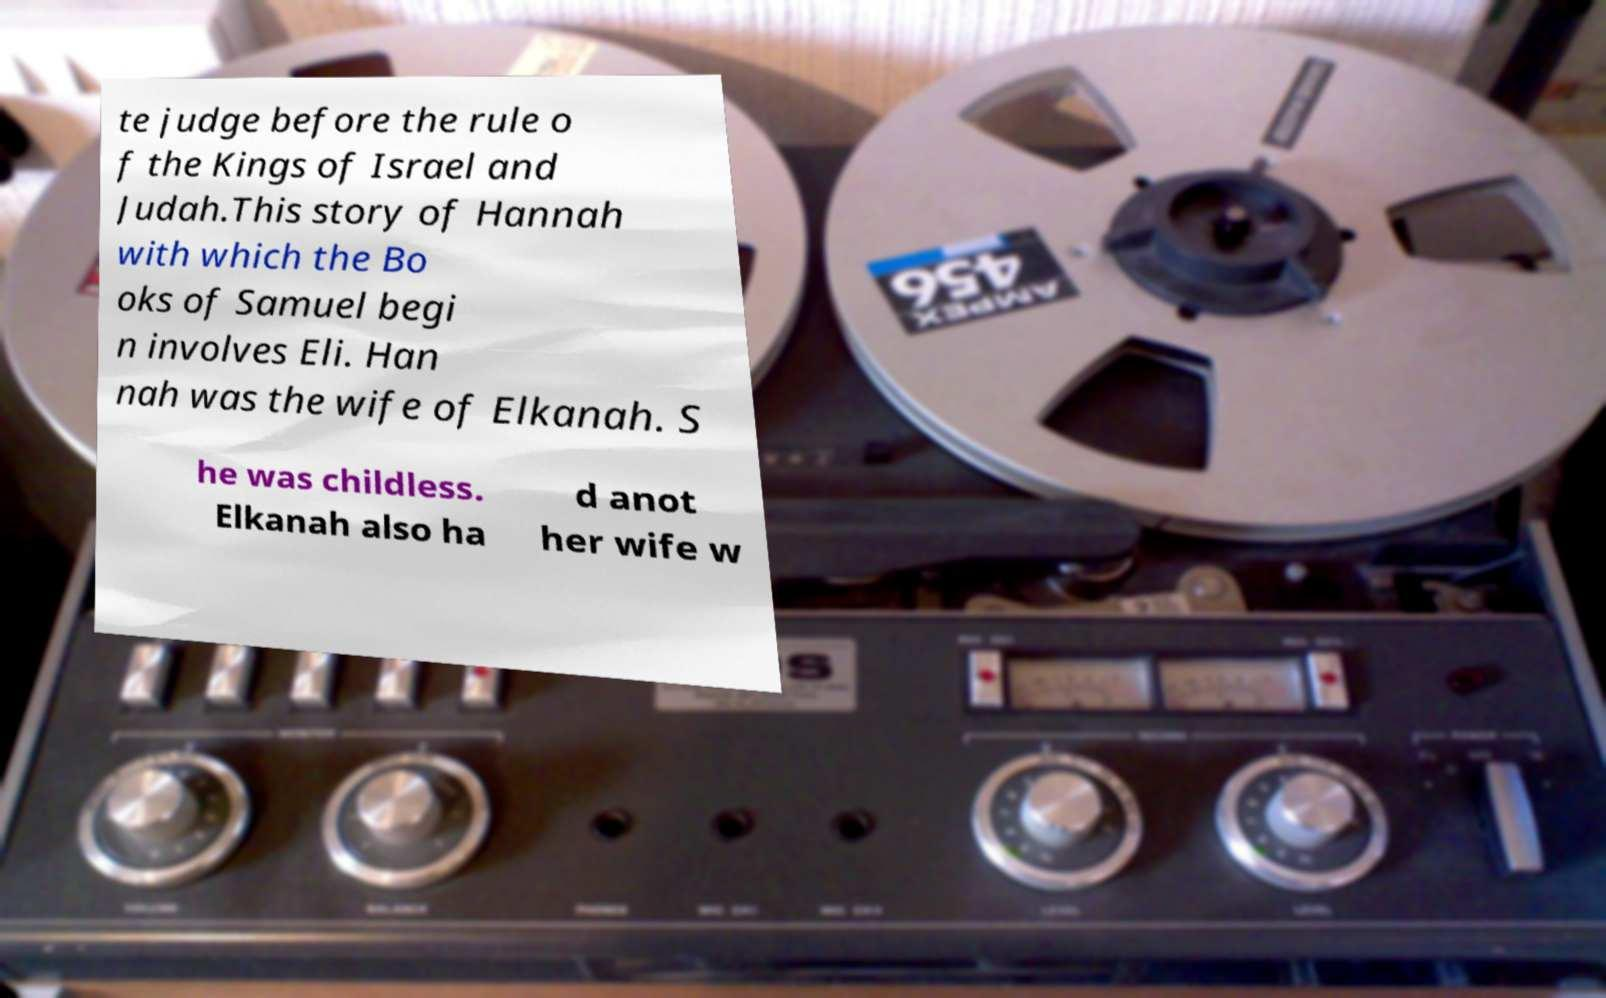There's text embedded in this image that I need extracted. Can you transcribe it verbatim? te judge before the rule o f the Kings of Israel and Judah.This story of Hannah with which the Bo oks of Samuel begi n involves Eli. Han nah was the wife of Elkanah. S he was childless. Elkanah also ha d anot her wife w 